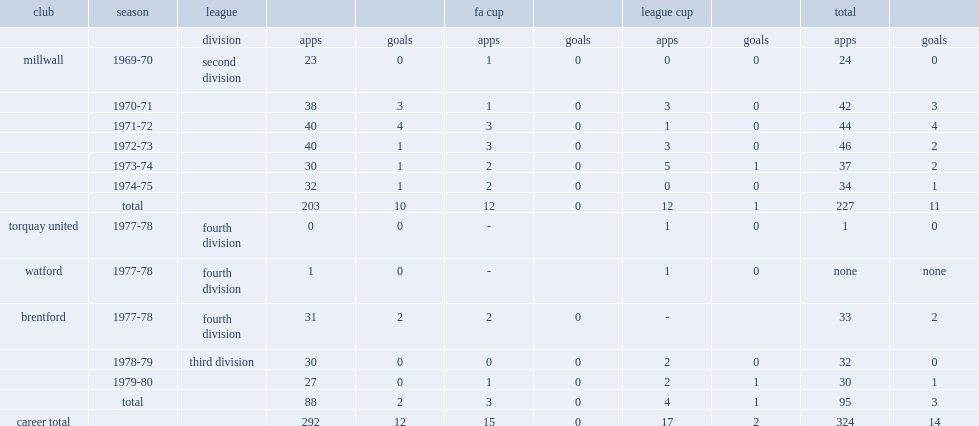Could you parse the entire table as a dict? {'header': ['club', 'season', 'league', '', '', 'fa cup', '', 'league cup', '', 'total', ''], 'rows': [['', '', 'division', 'apps', 'goals', 'apps', 'goals', 'apps', 'goals', 'apps', 'goals'], ['millwall', '1969-70', 'second division', '23', '0', '1', '0', '0', '0', '24', '0'], ['', '1970-71', '', '38', '3', '1', '0', '3', '0', '42', '3'], ['', '1971-72', '', '40', '4', '3', '0', '1', '0', '44', '4'], ['', '1972-73', '', '40', '1', '3', '0', '3', '0', '46', '2'], ['', '1973-74', '', '30', '1', '2', '0', '5', '1', '37', '2'], ['', '1974-75', '', '32', '1', '2', '0', '0', '0', '34', '1'], ['', 'total', '', '203', '10', '12', '0', '12', '1', '227', '11'], ['torquay united', '1977-78', 'fourth division', '0', '0', '-', '', '1', '0', '1', '0'], ['watford', '1977-78', 'fourth division', '1', '0', '-', '', '1', '0', 'none', 'none'], ['brentford', '1977-78', 'fourth division', '31', '2', '2', '0', '-', '', '33', '2'], ['', '1978-79', 'third division', '30', '0', '0', '0', '2', '0', '32', '0'], ['', '1979-80', '', '27', '0', '1', '0', '2', '1', '30', '1'], ['', 'total', '', '88', '2', '3', '0', '4', '1', '95', '3'], ['career total', '', '', '292', '12', '15', '0', '17', '2', '324', '14']]} How many appearances did doug allder make with millwall in six years? 227.0. 